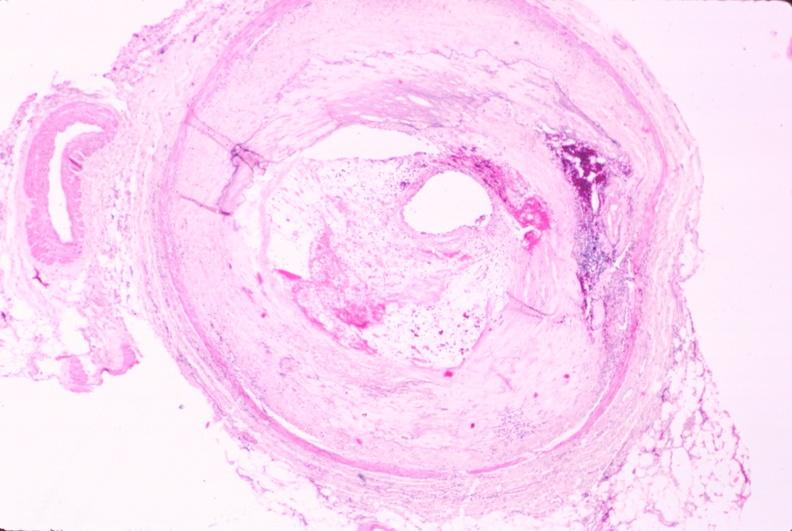does this image show atherosclerosis?
Answer the question using a single word or phrase. Yes 